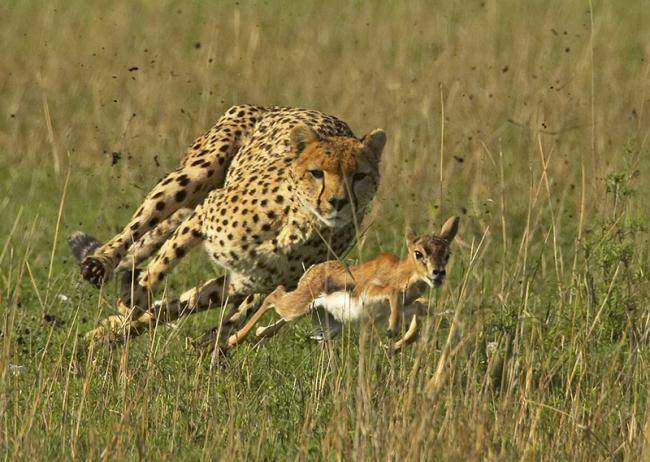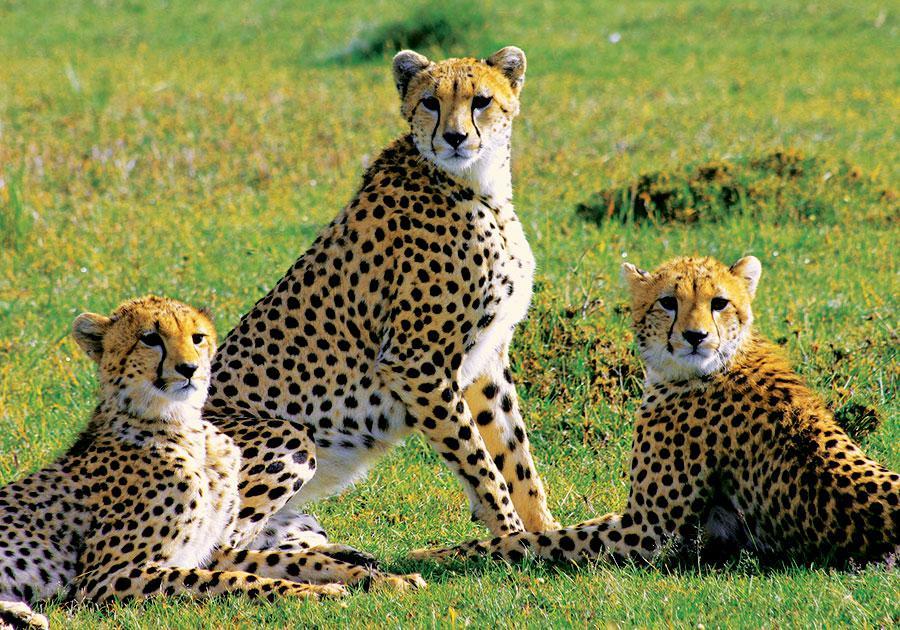The first image is the image on the left, the second image is the image on the right. Evaluate the accuracy of this statement regarding the images: "The leopard on the left is running after its prey.". Is it true? Answer yes or no. Yes. The first image is the image on the left, the second image is the image on the right. Considering the images on both sides, is "An image shows one spotted wild cat pursuing its prey." valid? Answer yes or no. Yes. 